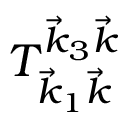<formula> <loc_0><loc_0><loc_500><loc_500>T _ { \vec { k } _ { 1 } \vec { k } } ^ { \vec { k } _ { 3 } \vec { k } }</formula> 